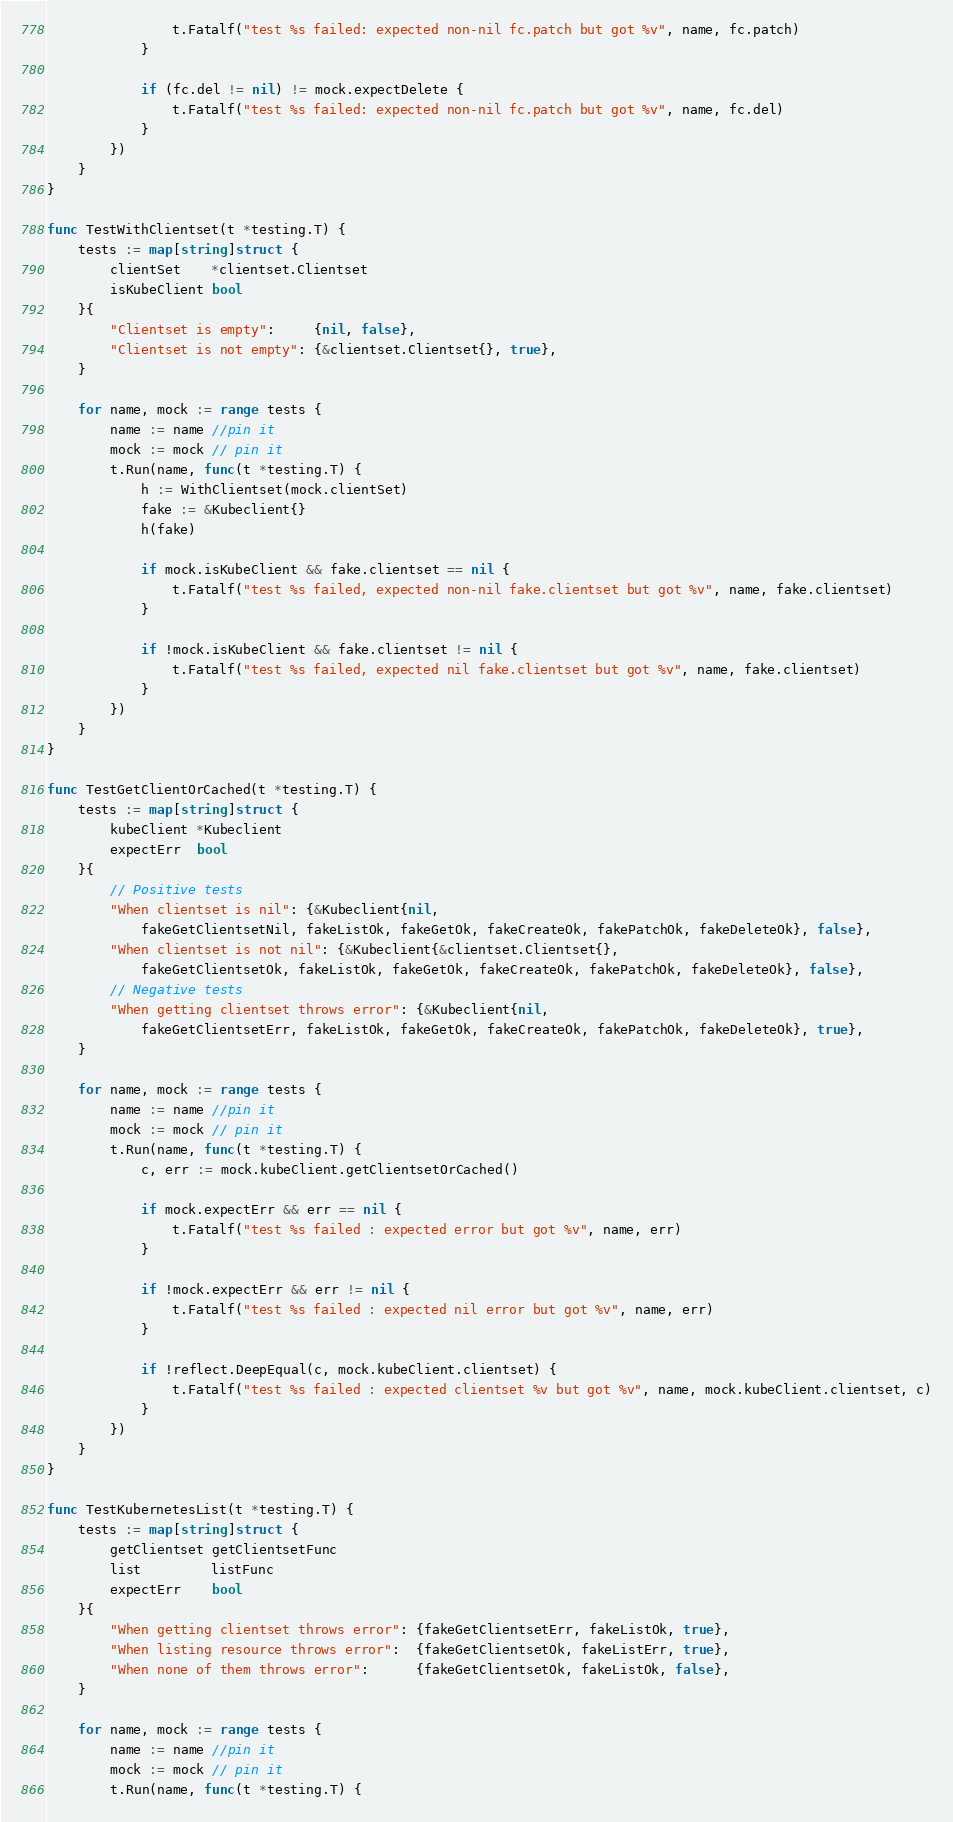<code> <loc_0><loc_0><loc_500><loc_500><_Go_>				t.Fatalf("test %s failed: expected non-nil fc.patch but got %v", name, fc.patch)
			}

			if (fc.del != nil) != mock.expectDelete {
				t.Fatalf("test %s failed: expected non-nil fc.patch but got %v", name, fc.del)
			}
		})
	}
}

func TestWithClientset(t *testing.T) {
	tests := map[string]struct {
		clientSet    *clientset.Clientset
		isKubeClient bool
	}{
		"Clientset is empty":     {nil, false},
		"Clientset is not empty": {&clientset.Clientset{}, true},
	}

	for name, mock := range tests {
		name := name //pin it
		mock := mock // pin it
		t.Run(name, func(t *testing.T) {
			h := WithClientset(mock.clientSet)
			fake := &Kubeclient{}
			h(fake)

			if mock.isKubeClient && fake.clientset == nil {
				t.Fatalf("test %s failed, expected non-nil fake.clientset but got %v", name, fake.clientset)
			}

			if !mock.isKubeClient && fake.clientset != nil {
				t.Fatalf("test %s failed, expected nil fake.clientset but got %v", name, fake.clientset)
			}
		})
	}
}

func TestGetClientOrCached(t *testing.T) {
	tests := map[string]struct {
		kubeClient *Kubeclient
		expectErr  bool
	}{
		// Positive tests
		"When clientset is nil": {&Kubeclient{nil,
			fakeGetClientsetNil, fakeListOk, fakeGetOk, fakeCreateOk, fakePatchOk, fakeDeleteOk}, false},
		"When clientset is not nil": {&Kubeclient{&clientset.Clientset{},
			fakeGetClientsetOk, fakeListOk, fakeGetOk, fakeCreateOk, fakePatchOk, fakeDeleteOk}, false},
		// Negative tests
		"When getting clientset throws error": {&Kubeclient{nil,
			fakeGetClientsetErr, fakeListOk, fakeGetOk, fakeCreateOk, fakePatchOk, fakeDeleteOk}, true},
	}

	for name, mock := range tests {
		name := name //pin it
		mock := mock // pin it
		t.Run(name, func(t *testing.T) {
			c, err := mock.kubeClient.getClientsetOrCached()

			if mock.expectErr && err == nil {
				t.Fatalf("test %s failed : expected error but got %v", name, err)
			}

			if !mock.expectErr && err != nil {
				t.Fatalf("test %s failed : expected nil error but got %v", name, err)
			}

			if !reflect.DeepEqual(c, mock.kubeClient.clientset) {
				t.Fatalf("test %s failed : expected clientset %v but got %v", name, mock.kubeClient.clientset, c)
			}
		})
	}
}

func TestKubernetesList(t *testing.T) {
	tests := map[string]struct {
		getClientset getClientsetFunc
		list         listFunc
		expectErr    bool
	}{
		"When getting clientset throws error": {fakeGetClientsetErr, fakeListOk, true},
		"When listing resource throws error":  {fakeGetClientsetOk, fakeListErr, true},
		"When none of them throws error":      {fakeGetClientsetOk, fakeListOk, false},
	}

	for name, mock := range tests {
		name := name //pin it
		mock := mock // pin it
		t.Run(name, func(t *testing.T) {</code> 